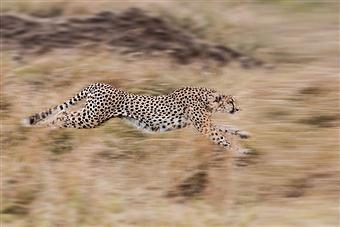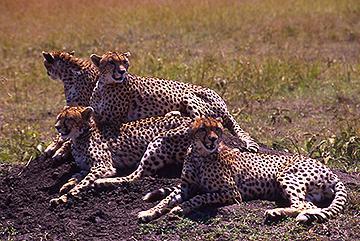The first image is the image on the left, the second image is the image on the right. Examine the images to the left and right. Is the description "At least one image shows an animal that is not a cheetah." accurate? Answer yes or no. No. The first image is the image on the left, the second image is the image on the right. For the images displayed, is the sentence "A cheetah's front paws are off the ground." factually correct? Answer yes or no. Yes. 